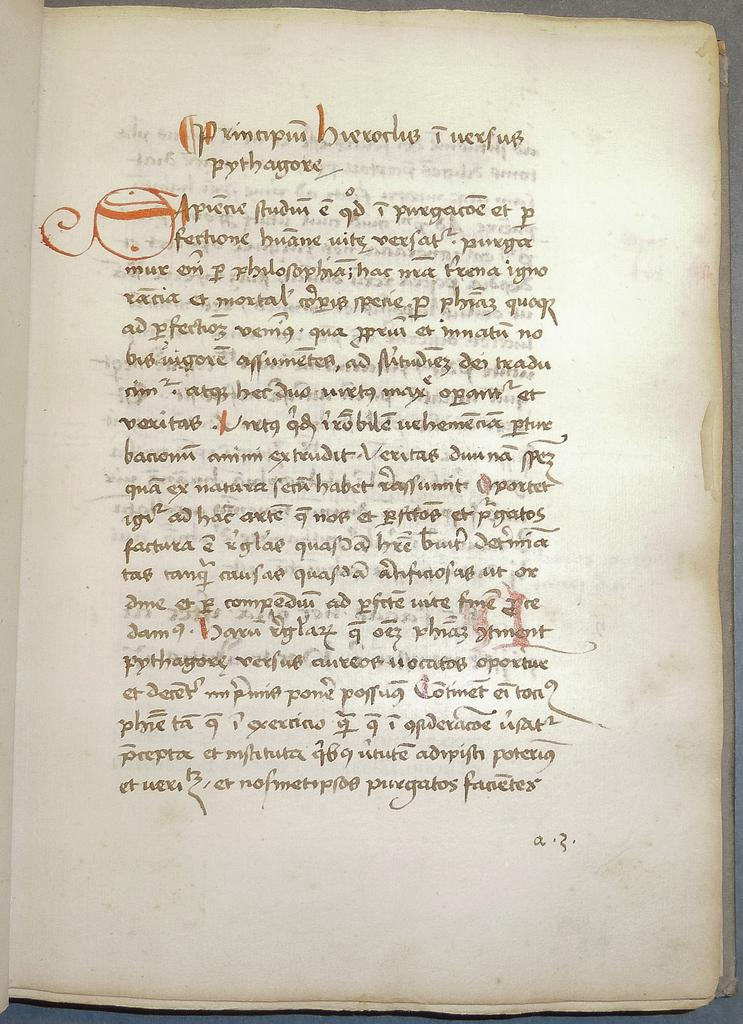<image>
Write a terse but informative summary of the picture. an old paper with a lot of writing in an indecipherable language 